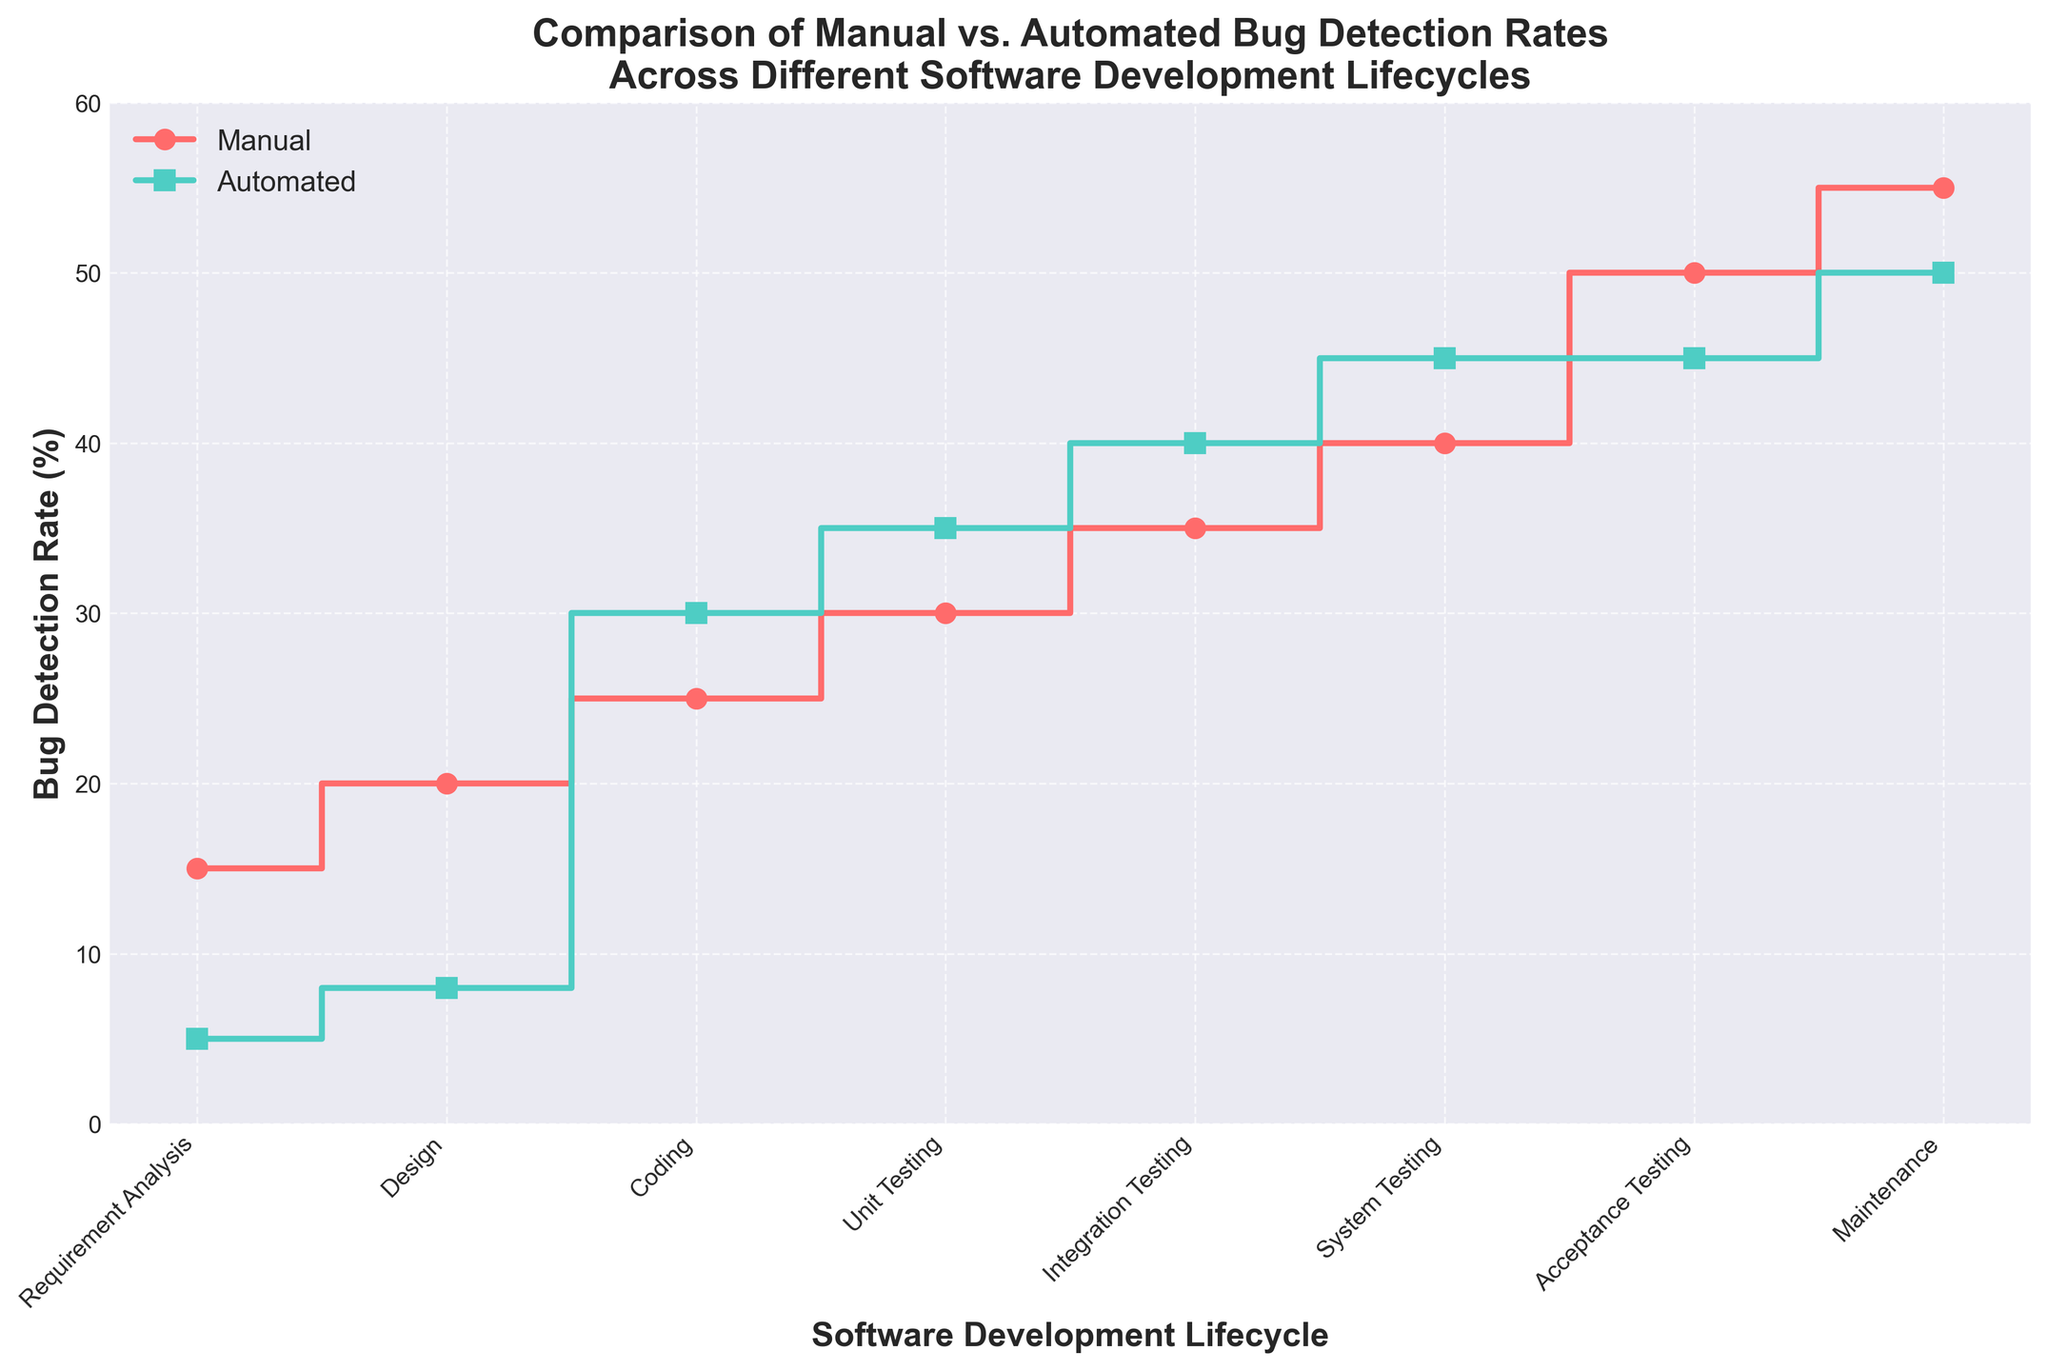What's the bug detection rate for manual testing during the coding phase? To find the manual detection rate during the coding phase, look at the detection rate value next to "Coding" on the manual line (usually marked with circle markers).
Answer: 25% What's the color of the plot line representing automated bug detection? The color of the plot line representing automated bug detection is visually distinguishable. The automated line is represented in a turquoise-green color.
Answer: Turquoise-green Which software development lifecycle phase has equal detection rates for both manual and automated methods? Observe the plot to find where both manual and automated lines converge. This occurs at the "Acceptance Testing" phase, where both methods have similar detection rates.
Answer: Acceptance Testing What is the detection rate difference between manual and automated methods during the maintenance phase? Subtract the automated detection rate from the manual detection rate during the maintenance phase. Manual rate is 55, and automated rate is 50. 55 - 50 = 5.
Answer: 5% Which method has a higher bug detection rate during the unit testing phase? Compare the detection rates in the unit testing phase for both methods. The detection rate for automated is higher (35) compared to manual (30).
Answer: Automated What is the average manual bug detection rate across all phases? Sum all the manual detection rates and divide by the number of lifecycle phases. The sum is 15+20+25+30+35+40+50+55 = 270. There are 8 phases. 270 / 8 = 33.75.
Answer: 33.75% Is there a phase where automated detection consistently outperforms manual detection? Automated detection outperforms manual detection starting from the coding phase through to the system testing phase, and comes close during the acceptance testing phase.
Answer: Coding to System Testing What is the difference in bug detection rates between the requirement analysis and system testing phases for the manual method? Subtract the manual rate in the requirement analysis phase from the manual rate in the system testing phase. Manual detection rate in system testing is 40 and in requirement analysis is 15. 40 - 15 = 25.
Answer: 25% How many unique software development lifecycle phases are plotted in the figure? Count the different phases on the x-axis. There are 8 unique phases listed: Requirement Analysis, Design, Coding, Unit Testing, Integration Testing, System Testing, Acceptance Testing, Maintenance.
Answer: 8 Which method shows the highest bug detection rate at any phase? Identify the highest detection rate on the y-axis for both methods. The manual method hits the highest rate of 55 during the maintenance phase, while the automated method peaks at 50 during the same phase. Hence, manual shows the highest detection rate.
Answer: Manual 